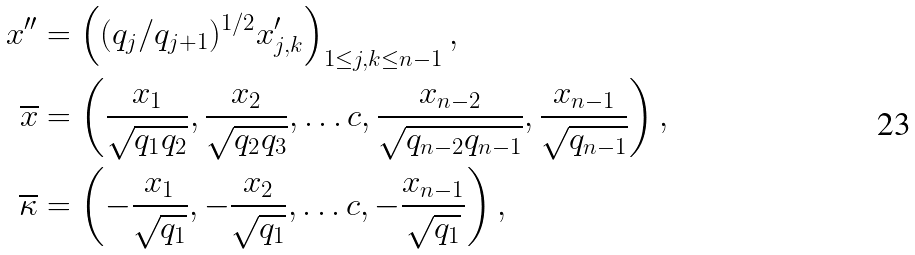Convert formula to latex. <formula><loc_0><loc_0><loc_500><loc_500>x ^ { \prime \prime } & = \left ( ( q _ { j } / q _ { j + 1 } ) ^ { 1 / 2 } x _ { j , k } ^ { \prime } \right ) _ { 1 \leq j , k \leq n - 1 } , \\ \overline { x } & = \left ( \frac { x _ { 1 } } { \sqrt { q _ { 1 } q _ { 2 } } } , \frac { x _ { 2 } } { \sqrt { q _ { 2 } q _ { 3 } } } , \dots c , \frac { x _ { n - 2 } } { \sqrt { q _ { n - 2 } q _ { n - 1 } } } , \frac { x _ { n - 1 } } { \sqrt { q _ { n - 1 } } } \right ) , \\ \overline { \kappa } & = \left ( - \frac { x _ { 1 } } { \sqrt { q _ { 1 } } } , - \frac { x _ { 2 } } { \sqrt { q _ { 1 } } } , \dots c , - \frac { x _ { n - 1 } } { \sqrt { q _ { 1 } } } \right ) ,</formula> 